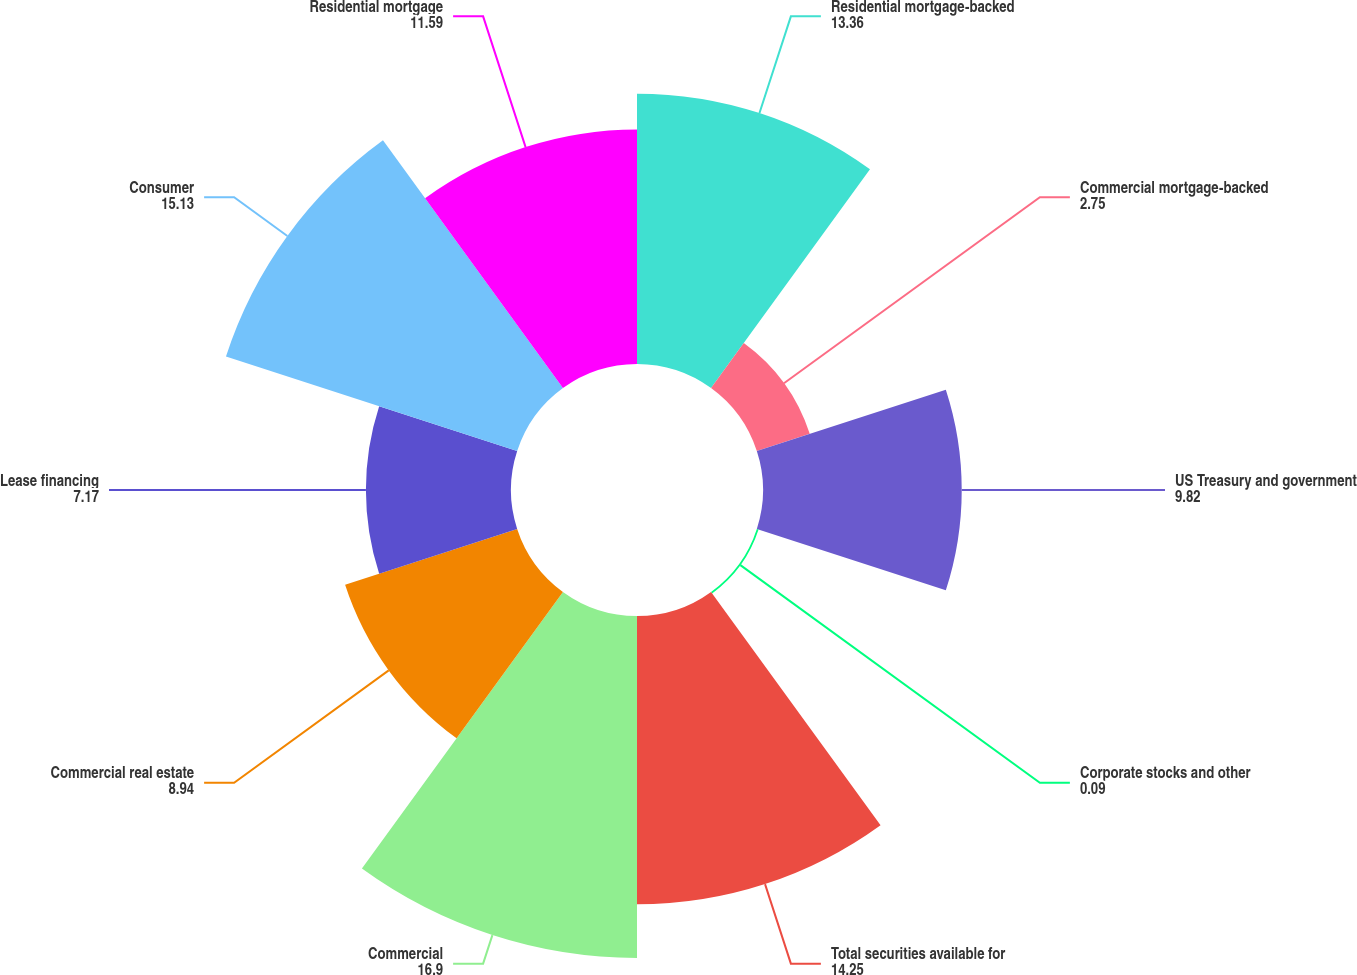<chart> <loc_0><loc_0><loc_500><loc_500><pie_chart><fcel>Residential mortgage-backed<fcel>Commercial mortgage-backed<fcel>US Treasury and government<fcel>Corporate stocks and other<fcel>Total securities available for<fcel>Commercial<fcel>Commercial real estate<fcel>Lease financing<fcel>Consumer<fcel>Residential mortgage<nl><fcel>13.36%<fcel>2.75%<fcel>9.82%<fcel>0.09%<fcel>14.25%<fcel>16.9%<fcel>8.94%<fcel>7.17%<fcel>15.13%<fcel>11.59%<nl></chart> 